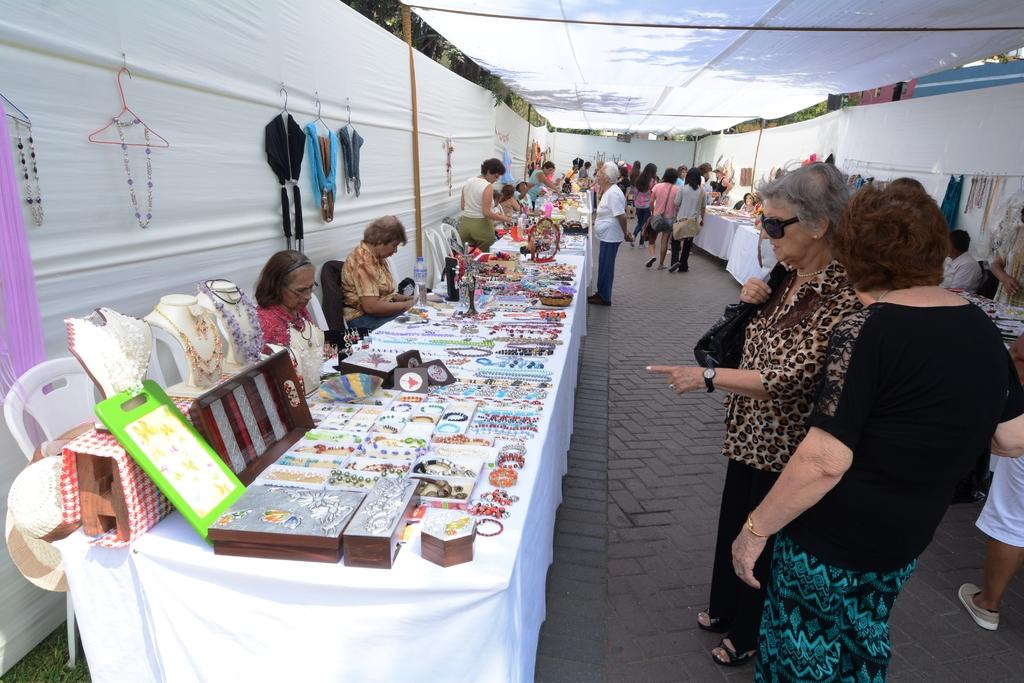What type of establishments can be seen in the image? There are shopping stalls in the image. What are the people at the stalls doing? People are sitting and selling at the stalls. What are some of the activities of the people in the image? People are walking and standing in the image. What color is the silver clover in the image? There is no silver clover present in the image. 